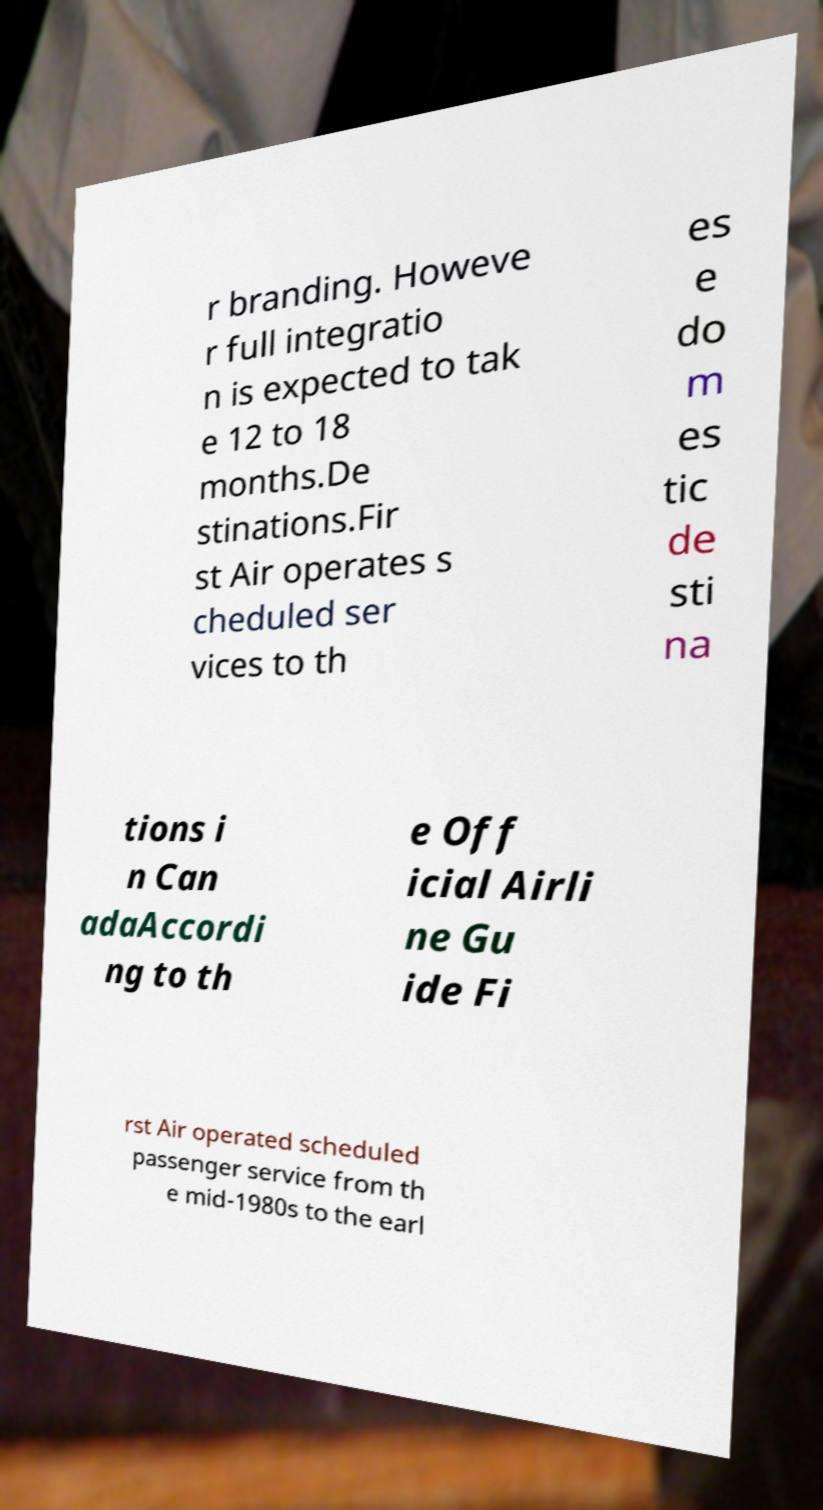Could you extract and type out the text from this image? r branding. Howeve r full integratio n is expected to tak e 12 to 18 months.De stinations.Fir st Air operates s cheduled ser vices to th es e do m es tic de sti na tions i n Can adaAccordi ng to th e Off icial Airli ne Gu ide Fi rst Air operated scheduled passenger service from th e mid-1980s to the earl 